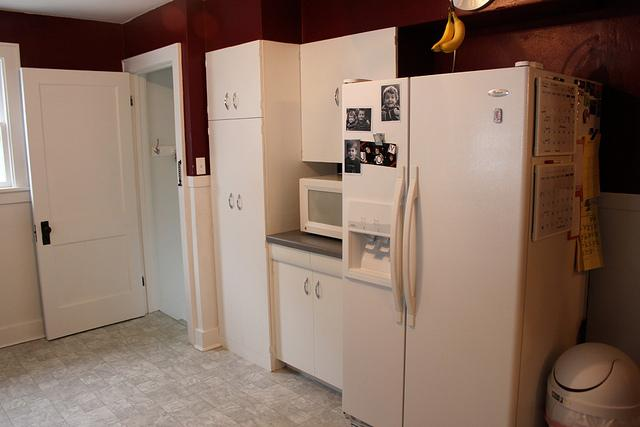What is the state of the bananas?

Choices:
A) overripe
B) ripe
C) underripe
D) rotten ripe 